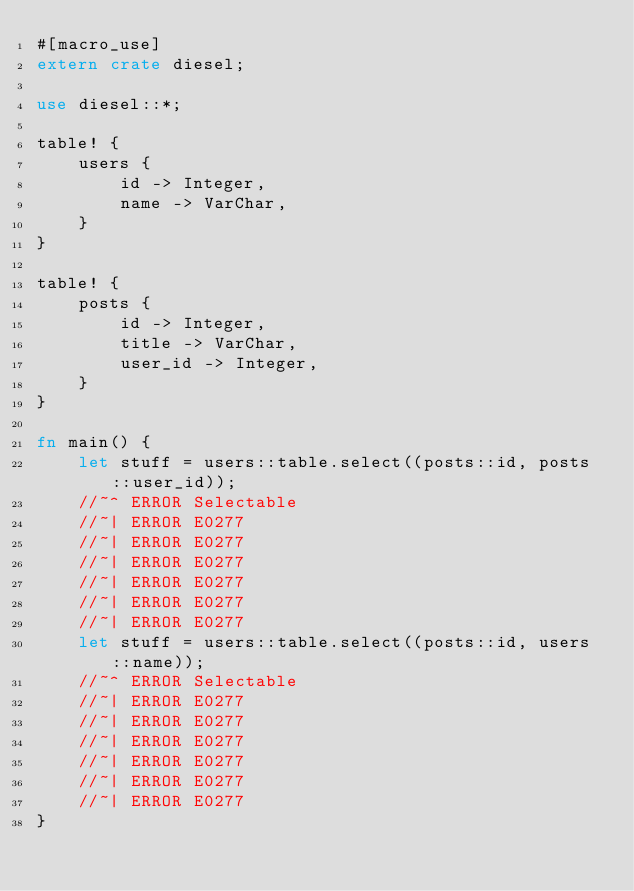Convert code to text. <code><loc_0><loc_0><loc_500><loc_500><_Rust_>#[macro_use]
extern crate diesel;

use diesel::*;

table! {
    users {
        id -> Integer,
        name -> VarChar,
    }
}

table! {
    posts {
        id -> Integer,
        title -> VarChar,
        user_id -> Integer,
    }
}

fn main() {
    let stuff = users::table.select((posts::id, posts::user_id));
    //~^ ERROR Selectable
    //~| ERROR E0277
    //~| ERROR E0277
    //~| ERROR E0277
    //~| ERROR E0277
    //~| ERROR E0277
    //~| ERROR E0277
    let stuff = users::table.select((posts::id, users::name));
    //~^ ERROR Selectable
    //~| ERROR E0277
    //~| ERROR E0277
    //~| ERROR E0277
    //~| ERROR E0277
    //~| ERROR E0277
    //~| ERROR E0277
}
</code> 